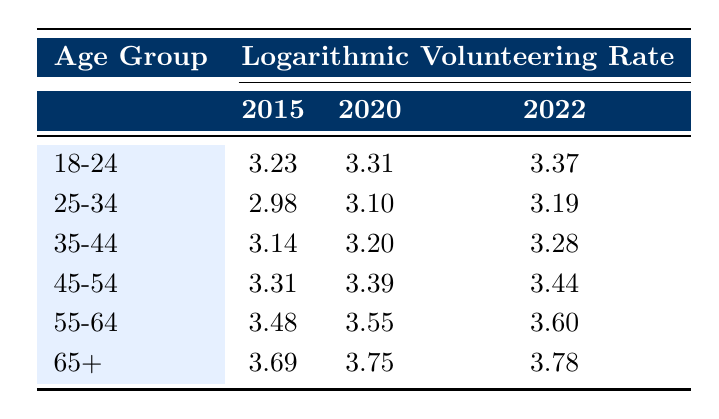What was the volunteering rate for the age group 45-54 in 2020? From the table, the volunteering rate for the age group 45-54 in 2020 is listed in the second column under the year 2020. It is 3.39 (logarithmic value) which corresponds to a volunteering rate of approximately 29.8% when converted back from logarithmic scale.
Answer: 3.39 Which age group had the highest volunteering rate in 2022? The table's last column for the year 2022 shows the volunteering rates for each age group. The age group 65+ has the highest logarithmic volunteering rate at 3.78.
Answer: 3.78 What is the difference in volunteering rates between the age groups 18-24 and 25-34 in 2022? In 2022, the volunteering rate for 18-24 is 3.37 and for 25-34 it is 3.19. To find the difference, we subtract the logarithmic value of the younger group from the older group (3.37 - 3.19 = 0.18).
Answer: 0.18 Was the volunteering rate for the age group 55-64 higher in 2020 compared to 2015? The volunteering rate for the age group 55-64 in 2020 is 3.55, while in 2015 it was 3.48. Since 3.55 > 3.48, the statement is true.
Answer: Yes What was the average volunteering rate of the age group 35-44 across all years? The volunteering rates for the age group 35-44 are 3.14 (2015), 3.20 (2020), and 3.28 (2022). To find the average, we sum them up (3.14 + 3.20 + 3.28 = 9.62) and divide by the number of years (3). Thus, the average is 9.62 / 3 = 3.21.
Answer: 3.21 Is it true that the volunteering rates for every age group increased from 2015 to 2022? We must compare the values of each age group for 2015 and 2022. We find that all rates increased: 3.23 to 3.37 (18-24), 2.98 to 3.19 (25-34), 3.14 to 3.28 (35-44), 3.31 to 3.44 (45-54), 3.48 to 3.60 (55-64), and 3.69 to 3.78 (65+). Since all reflect an increase, the answer is yes.
Answer: Yes 